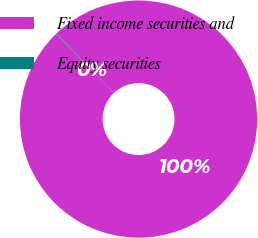Convert chart to OTSL. <chart><loc_0><loc_0><loc_500><loc_500><pie_chart><fcel>Fixed income securities and<fcel>Equity securities<nl><fcel>99.93%<fcel>0.07%<nl></chart> 